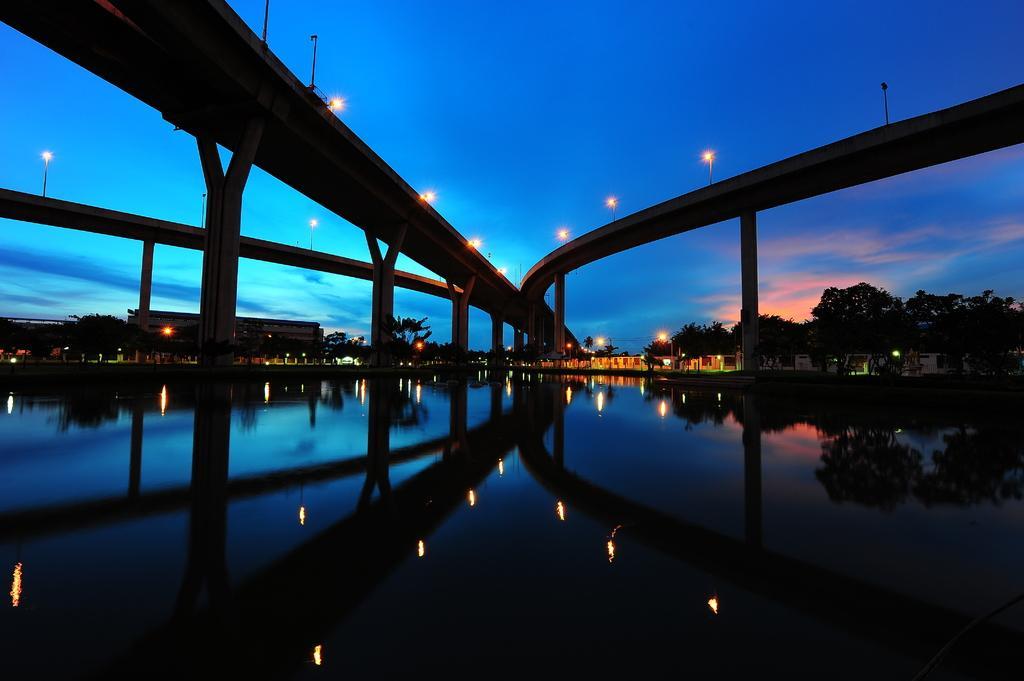Please provide a concise description of this image. In this picture I can see some lights to the bridge, down I can see water flow, behind there are some buildings and trees. 